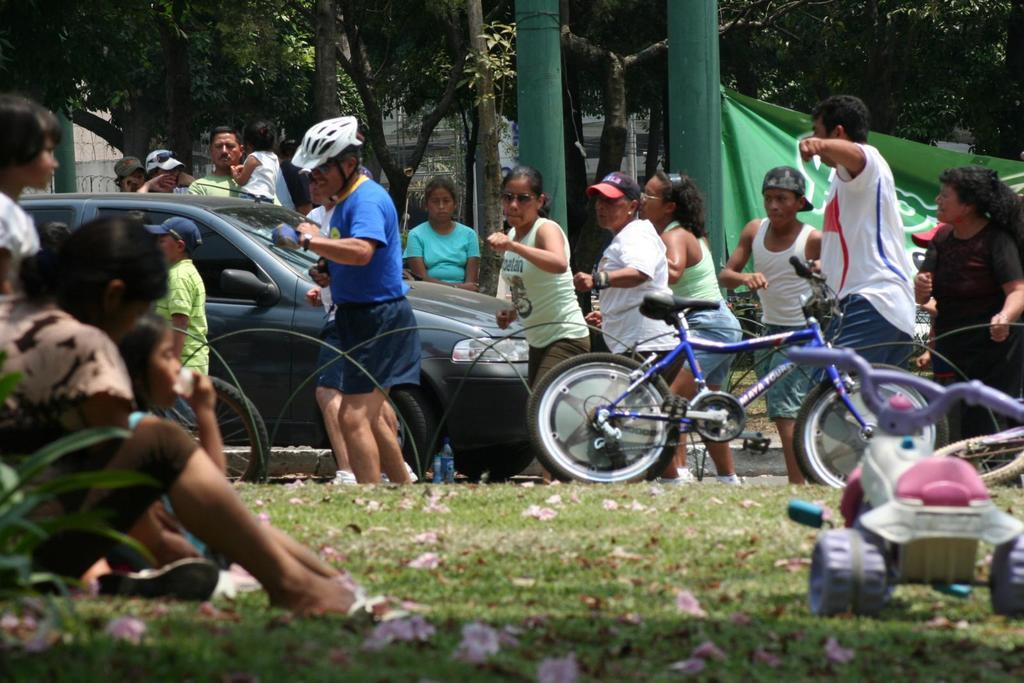How many people can be seen in the image? There are persons in the image, but the exact number is not specified. What type of vehicle is present in the image? There is a bicycle and a car in the image. What is the setting of the image? The image features a road, grass, flowers, trees, a banner, and buildings. What might the persons in the image be doing? It is not clear from the facts what the persons are doing, but they could be interacting with the bicycle, car, or other elements in the image. What type of pancake is being used to light the bicycle in the image? There is no pancake or lighting of the bicycle present in the image. 